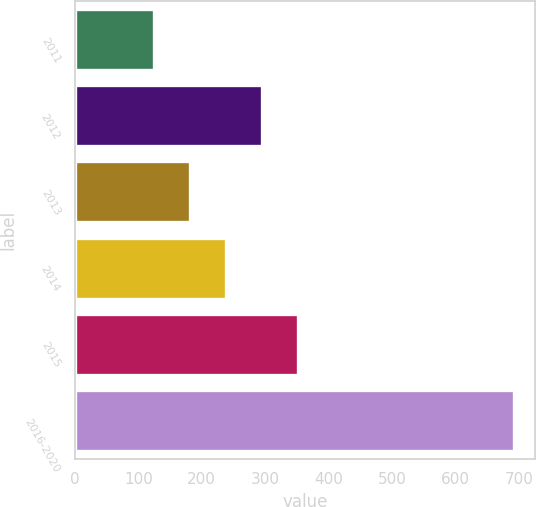Convert chart to OTSL. <chart><loc_0><loc_0><loc_500><loc_500><bar_chart><fcel>2011<fcel>2012<fcel>2013<fcel>2014<fcel>2015<fcel>2016-2020<nl><fcel>125.4<fcel>295.2<fcel>182<fcel>238.6<fcel>351.8<fcel>691.4<nl></chart> 